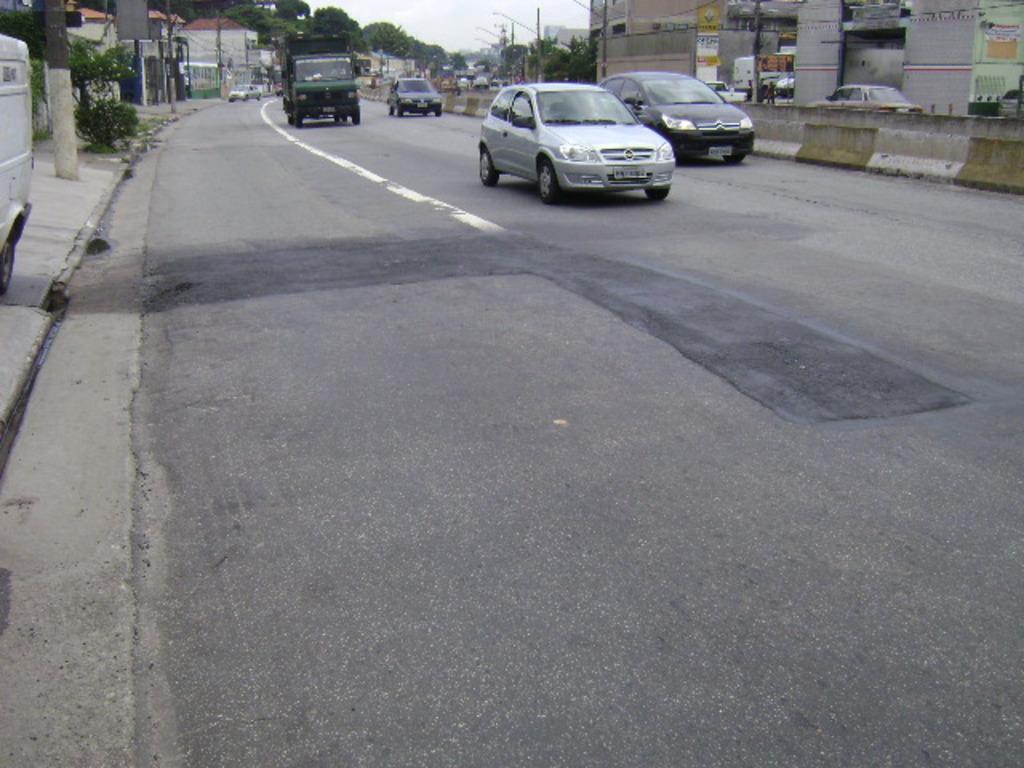In one or two sentences, can you explain what this image depicts? On the left side, there is a vehicle, a tree and a plant on a footpath. On the right side, there are vehicles on the road and there is a fence. In the background, there are buildings, trees, poles and there are clouds in the sky. 